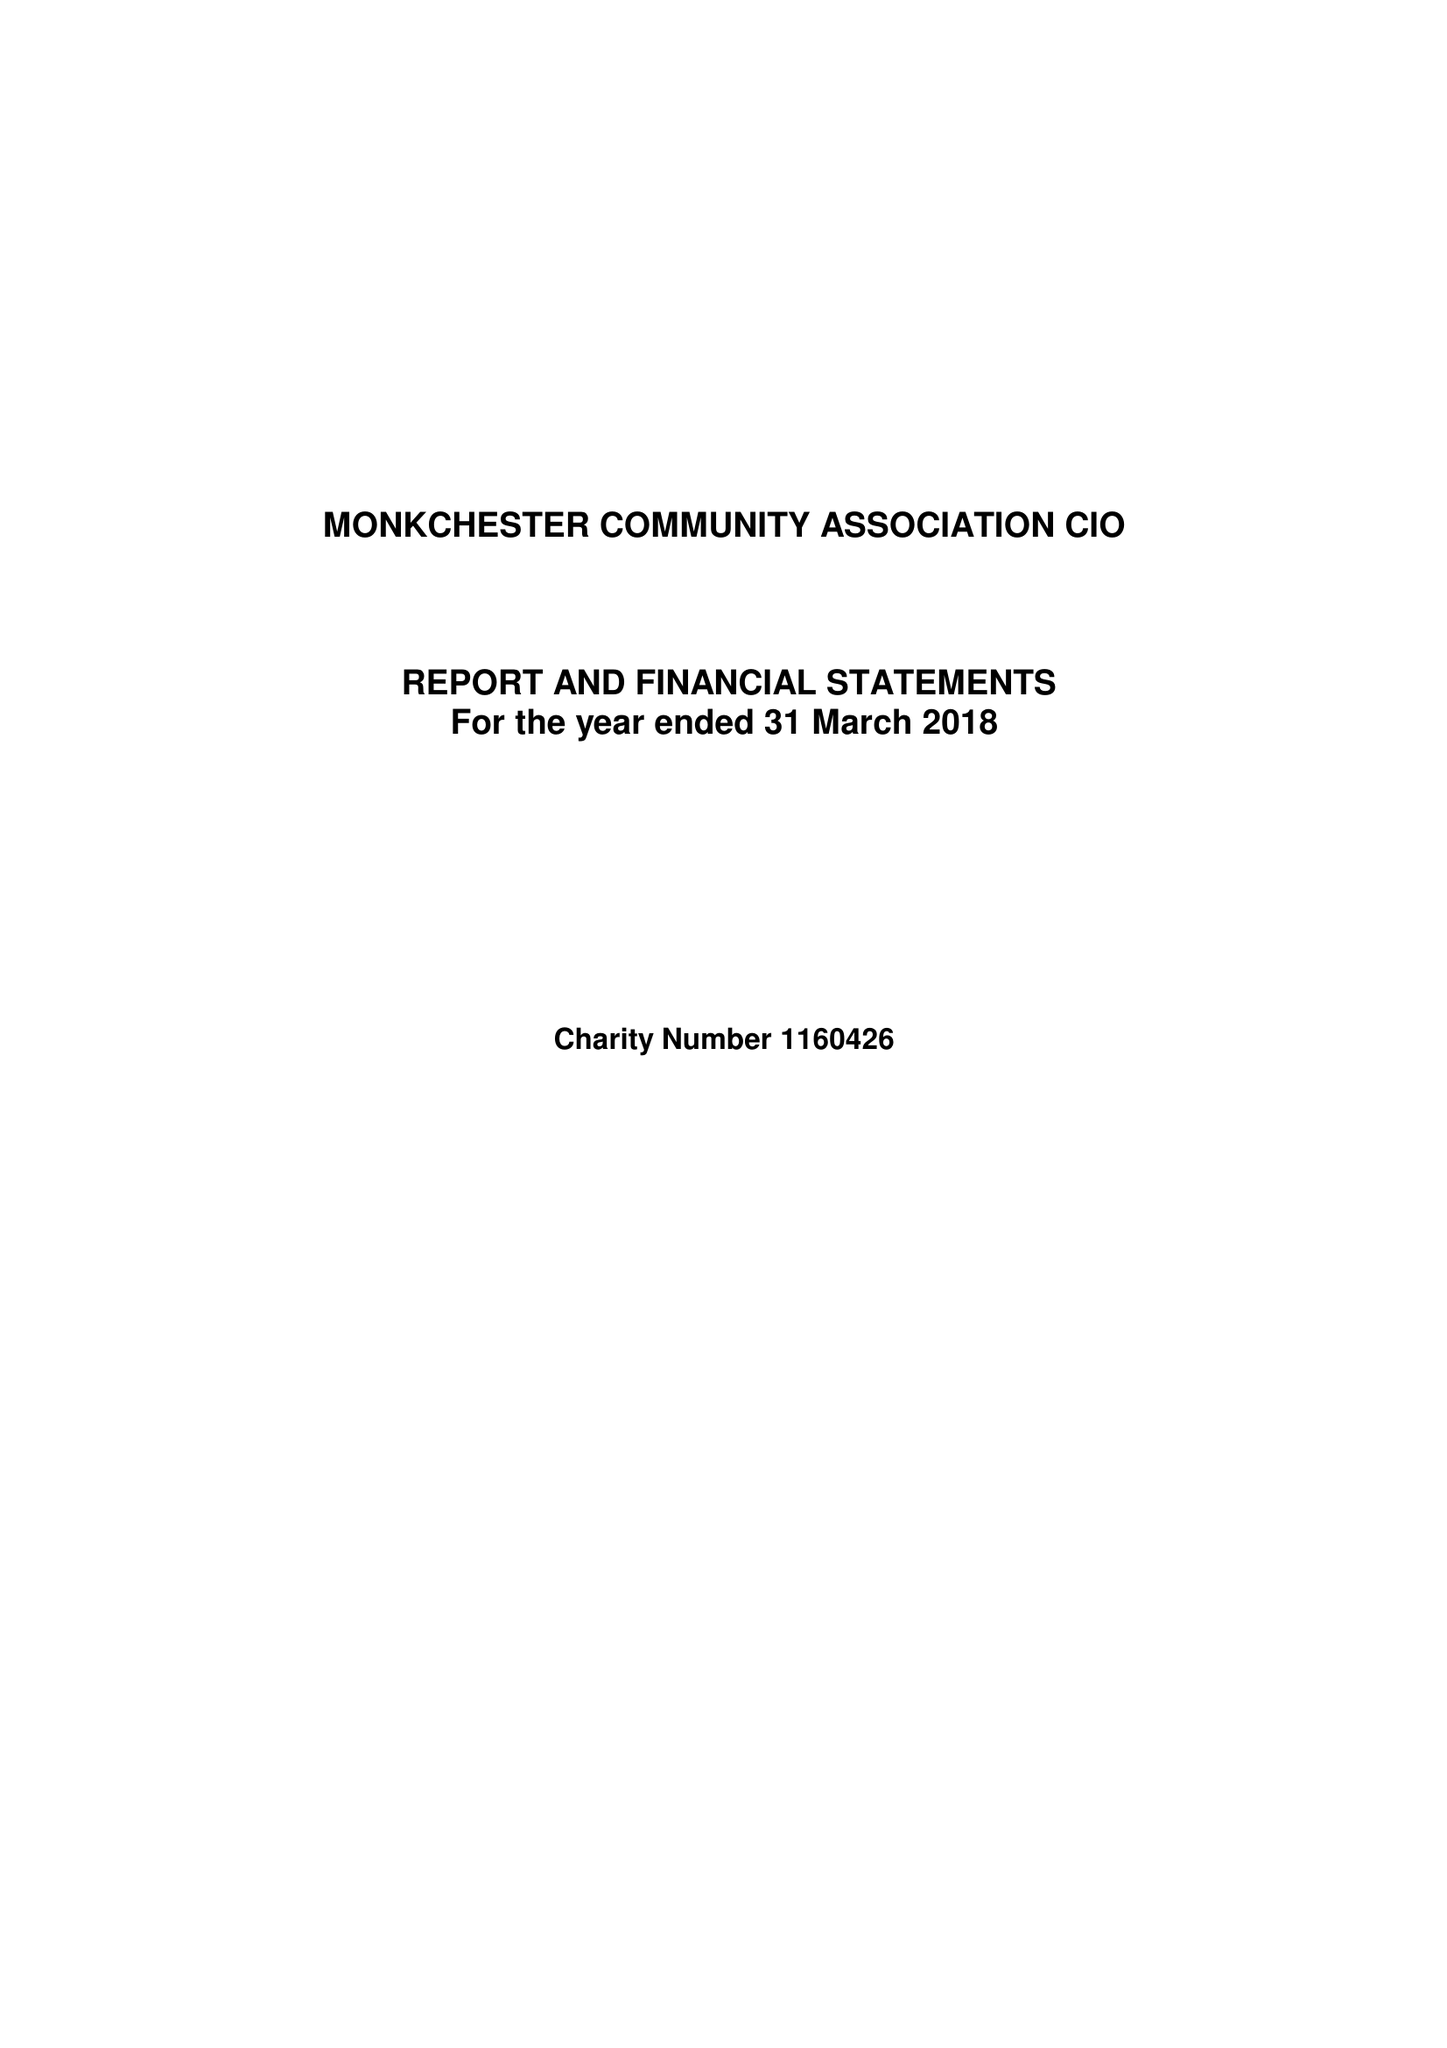What is the value for the income_annually_in_british_pounds?
Answer the question using a single word or phrase. 21790.00 